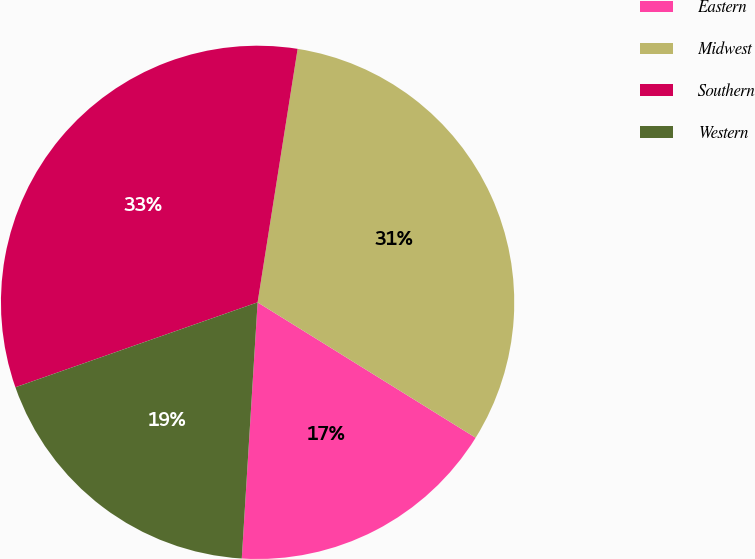Convert chart. <chart><loc_0><loc_0><loc_500><loc_500><pie_chart><fcel>Eastern<fcel>Midwest<fcel>Southern<fcel>Western<nl><fcel>17.14%<fcel>31.35%<fcel>32.86%<fcel>18.65%<nl></chart> 